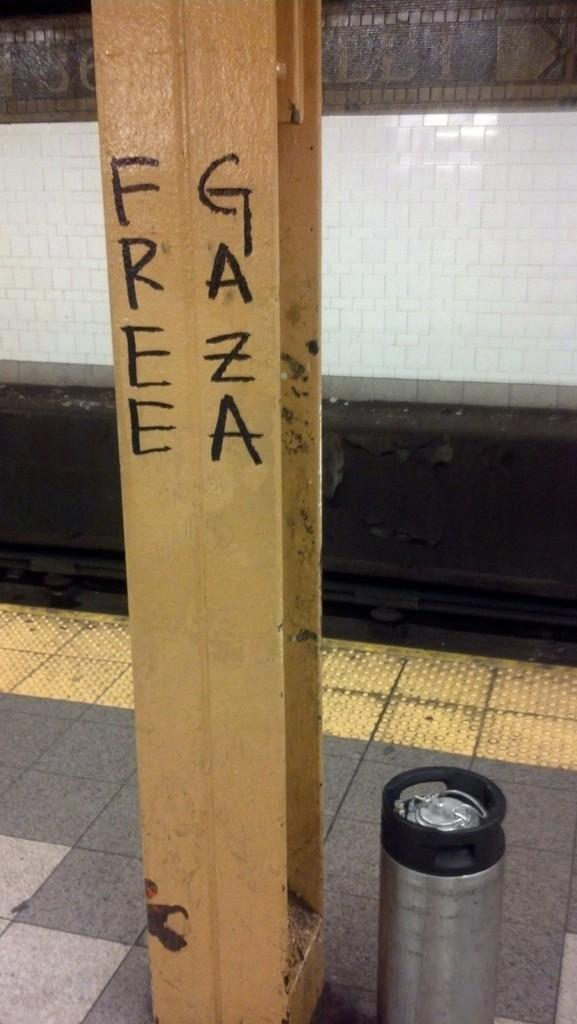Provide a one-sentence caption for the provided image. A steel beam that has Free Gaza on it. 